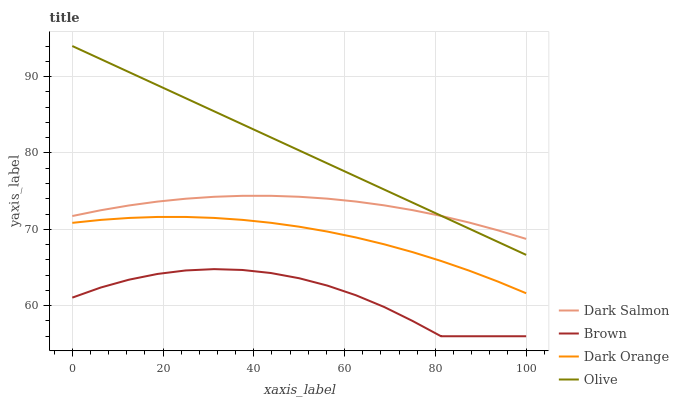Does Brown have the minimum area under the curve?
Answer yes or no. Yes. Does Olive have the maximum area under the curve?
Answer yes or no. Yes. Does Dark Salmon have the minimum area under the curve?
Answer yes or no. No. Does Dark Salmon have the maximum area under the curve?
Answer yes or no. No. Is Olive the smoothest?
Answer yes or no. Yes. Is Brown the roughest?
Answer yes or no. Yes. Is Dark Salmon the smoothest?
Answer yes or no. No. Is Dark Salmon the roughest?
Answer yes or no. No. Does Brown have the lowest value?
Answer yes or no. Yes. Does Dark Salmon have the lowest value?
Answer yes or no. No. Does Olive have the highest value?
Answer yes or no. Yes. Does Dark Salmon have the highest value?
Answer yes or no. No. Is Brown less than Olive?
Answer yes or no. Yes. Is Dark Salmon greater than Dark Orange?
Answer yes or no. Yes. Does Olive intersect Dark Salmon?
Answer yes or no. Yes. Is Olive less than Dark Salmon?
Answer yes or no. No. Is Olive greater than Dark Salmon?
Answer yes or no. No. Does Brown intersect Olive?
Answer yes or no. No. 